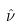Convert formula to latex. <formula><loc_0><loc_0><loc_500><loc_500>\hat { \nu }</formula> 